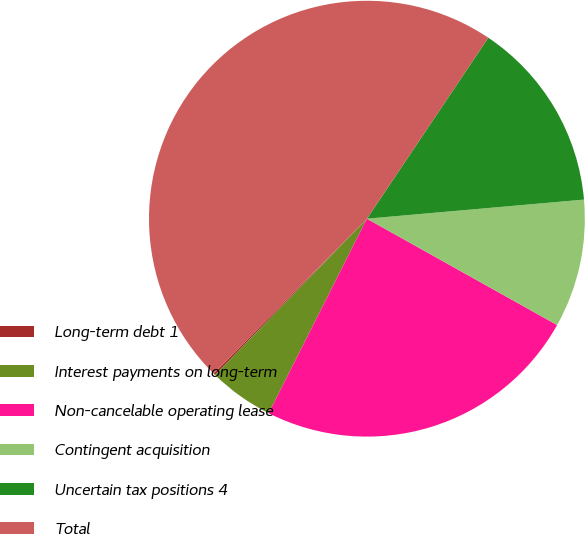Convert chart to OTSL. <chart><loc_0><loc_0><loc_500><loc_500><pie_chart><fcel>Long-term debt 1<fcel>Interest payments on long-term<fcel>Non-cancelable operating lease<fcel>Contingent acquisition<fcel>Uncertain tax positions 4<fcel>Total<nl><fcel>0.14%<fcel>4.83%<fcel>24.33%<fcel>9.51%<fcel>14.2%<fcel>46.99%<nl></chart> 